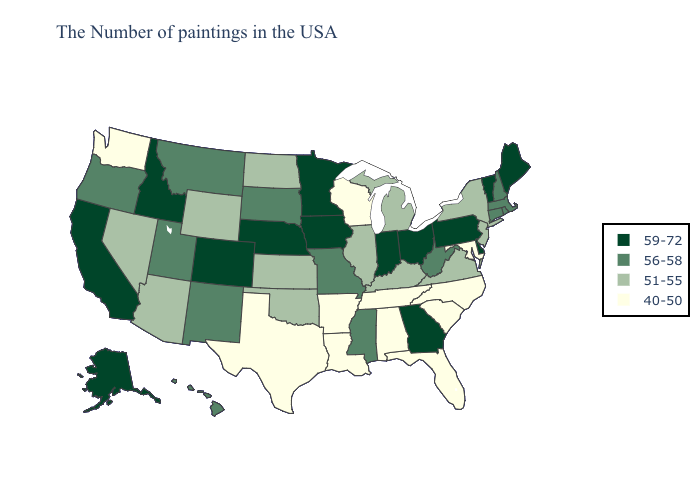What is the lowest value in the USA?
Answer briefly. 40-50. What is the lowest value in the MidWest?
Short answer required. 40-50. Does Virginia have the highest value in the USA?
Keep it brief. No. What is the highest value in the West ?
Give a very brief answer. 59-72. What is the value of Rhode Island?
Short answer required. 56-58. How many symbols are there in the legend?
Write a very short answer. 4. How many symbols are there in the legend?
Be succinct. 4. What is the highest value in the Northeast ?
Keep it brief. 59-72. What is the value of Arizona?
Write a very short answer. 51-55. Among the states that border Wyoming , which have the highest value?
Quick response, please. Nebraska, Colorado, Idaho. Does California have the highest value in the USA?
Short answer required. Yes. What is the value of Virginia?
Concise answer only. 51-55. What is the value of Ohio?
Answer briefly. 59-72. Name the states that have a value in the range 59-72?
Quick response, please. Maine, Vermont, Delaware, Pennsylvania, Ohio, Georgia, Indiana, Minnesota, Iowa, Nebraska, Colorado, Idaho, California, Alaska. What is the lowest value in the USA?
Short answer required. 40-50. 